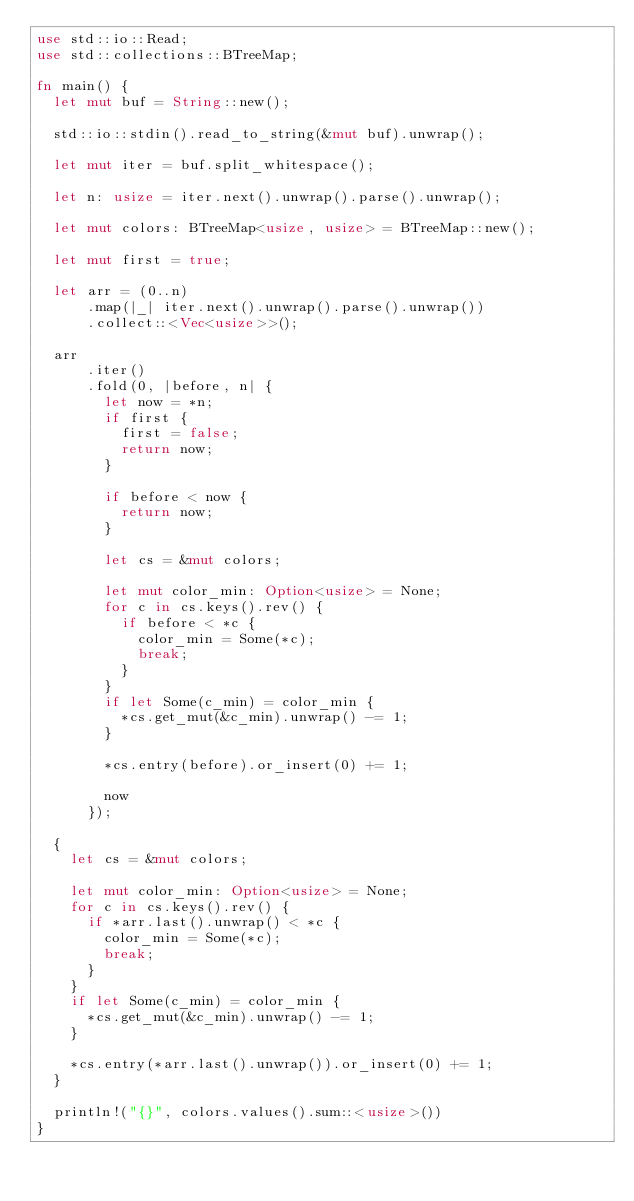<code> <loc_0><loc_0><loc_500><loc_500><_Rust_>use std::io::Read;
use std::collections::BTreeMap;

fn main() {
  let mut buf = String::new();

  std::io::stdin().read_to_string(&mut buf).unwrap();

  let mut iter = buf.split_whitespace();

  let n: usize = iter.next().unwrap().parse().unwrap();

  let mut colors: BTreeMap<usize, usize> = BTreeMap::new();

  let mut first = true;

  let arr = (0..n)
      .map(|_| iter.next().unwrap().parse().unwrap())
      .collect::<Vec<usize>>();

  arr
      .iter()
      .fold(0, |before, n| {
        let now = *n;
        if first {
          first = false;
          return now;
        }

        if before < now {
          return now;
        }
        
        let cs = &mut colors;

        let mut color_min: Option<usize> = None;
        for c in cs.keys().rev() {
          if before < *c {
            color_min = Some(*c);
            break;
          }
        }
        if let Some(c_min) = color_min {
          *cs.get_mut(&c_min).unwrap() -= 1;
        }

        *cs.entry(before).or_insert(0) += 1;

        now
      });

  {
    let cs = &mut colors;
    
    let mut color_min: Option<usize> = None;
    for c in cs.keys().rev() {
      if *arr.last().unwrap() < *c {
        color_min = Some(*c);
        break;
      }
    }
    if let Some(c_min) = color_min {
      *cs.get_mut(&c_min).unwrap() -= 1;
    }

    *cs.entry(*arr.last().unwrap()).or_insert(0) += 1;
  }
  
  println!("{}", colors.values().sum::<usize>())
}
</code> 